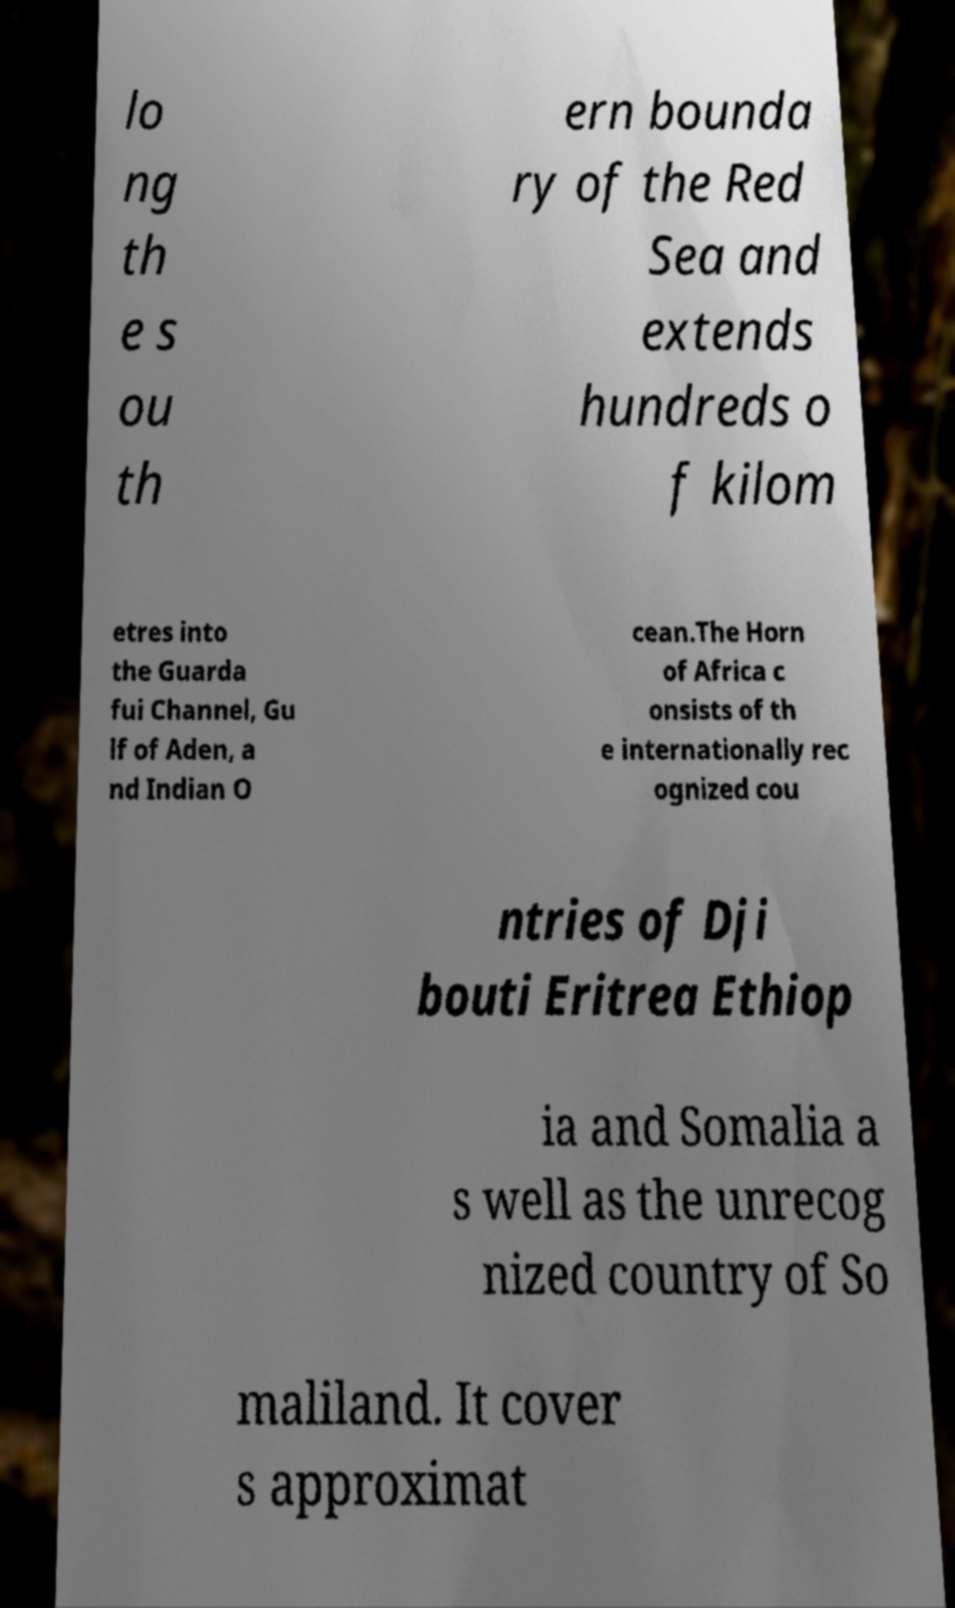Could you assist in decoding the text presented in this image and type it out clearly? lo ng th e s ou th ern bounda ry of the Red Sea and extends hundreds o f kilom etres into the Guarda fui Channel, Gu lf of Aden, a nd Indian O cean.The Horn of Africa c onsists of th e internationally rec ognized cou ntries of Dji bouti Eritrea Ethiop ia and Somalia a s well as the unrecog nized country of So maliland. It cover s approximat 